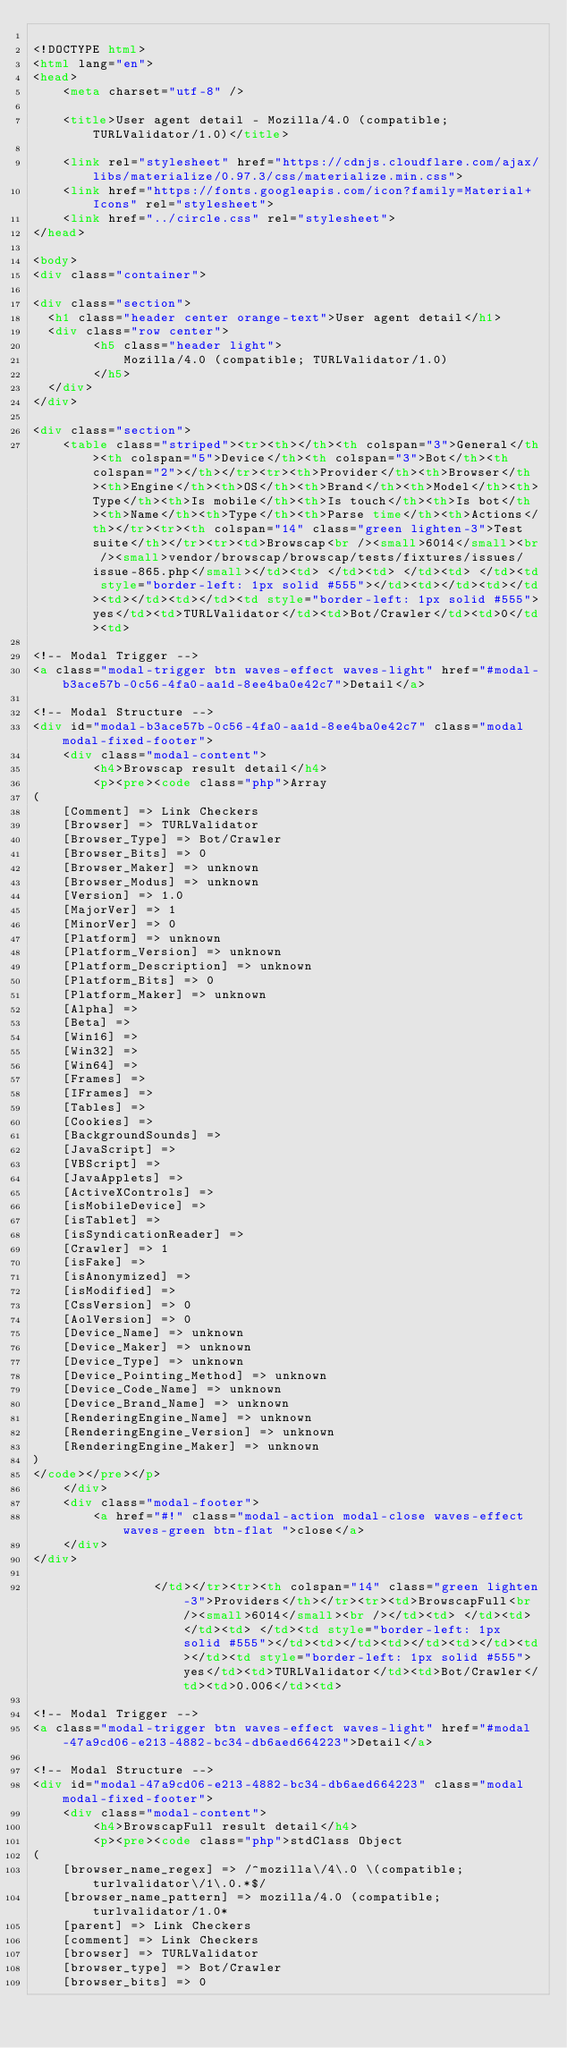Convert code to text. <code><loc_0><loc_0><loc_500><loc_500><_HTML_>
<!DOCTYPE html>
<html lang="en">
<head>
    <meta charset="utf-8" />
            
    <title>User agent detail - Mozilla/4.0 (compatible; TURLValidator/1.0)</title>
        
    <link rel="stylesheet" href="https://cdnjs.cloudflare.com/ajax/libs/materialize/0.97.3/css/materialize.min.css">
    <link href="https://fonts.googleapis.com/icon?family=Material+Icons" rel="stylesheet">
    <link href="../circle.css" rel="stylesheet">
</head>
        
<body>
<div class="container">
    
<div class="section">
	<h1 class="header center orange-text">User agent detail</h1>
	<div class="row center">
        <h5 class="header light">
            Mozilla/4.0 (compatible; TURLValidator/1.0)
        </h5>
	</div>
</div>   

<div class="section">
    <table class="striped"><tr><th></th><th colspan="3">General</th><th colspan="5">Device</th><th colspan="3">Bot</th><th colspan="2"></th></tr><tr><th>Provider</th><th>Browser</th><th>Engine</th><th>OS</th><th>Brand</th><th>Model</th><th>Type</th><th>Is mobile</th><th>Is touch</th><th>Is bot</th><th>Name</th><th>Type</th><th>Parse time</th><th>Actions</th></tr><tr><th colspan="14" class="green lighten-3">Test suite</th></tr><tr><td>Browscap<br /><small>6014</small><br /><small>vendor/browscap/browscap/tests/fixtures/issues/issue-865.php</small></td><td> </td><td> </td><td> </td><td style="border-left: 1px solid #555"></td><td></td><td></td><td></td><td></td><td style="border-left: 1px solid #555">yes</td><td>TURLValidator</td><td>Bot/Crawler</td><td>0</td><td>
        
<!-- Modal Trigger -->
<a class="modal-trigger btn waves-effect waves-light" href="#modal-b3ace57b-0c56-4fa0-aa1d-8ee4ba0e42c7">Detail</a>
        
<!-- Modal Structure -->
<div id="modal-b3ace57b-0c56-4fa0-aa1d-8ee4ba0e42c7" class="modal modal-fixed-footer">
    <div class="modal-content">
        <h4>Browscap result detail</h4>
        <p><pre><code class="php">Array
(
    [Comment] => Link Checkers
    [Browser] => TURLValidator
    [Browser_Type] => Bot/Crawler
    [Browser_Bits] => 0
    [Browser_Maker] => unknown
    [Browser_Modus] => unknown
    [Version] => 1.0
    [MajorVer] => 1
    [MinorVer] => 0
    [Platform] => unknown
    [Platform_Version] => unknown
    [Platform_Description] => unknown
    [Platform_Bits] => 0
    [Platform_Maker] => unknown
    [Alpha] => 
    [Beta] => 
    [Win16] => 
    [Win32] => 
    [Win64] => 
    [Frames] => 
    [IFrames] => 
    [Tables] => 
    [Cookies] => 
    [BackgroundSounds] => 
    [JavaScript] => 
    [VBScript] => 
    [JavaApplets] => 
    [ActiveXControls] => 
    [isMobileDevice] => 
    [isTablet] => 
    [isSyndicationReader] => 
    [Crawler] => 1
    [isFake] => 
    [isAnonymized] => 
    [isModified] => 
    [CssVersion] => 0
    [AolVersion] => 0
    [Device_Name] => unknown
    [Device_Maker] => unknown
    [Device_Type] => unknown
    [Device_Pointing_Method] => unknown
    [Device_Code_Name] => unknown
    [Device_Brand_Name] => unknown
    [RenderingEngine_Name] => unknown
    [RenderingEngine_Version] => unknown
    [RenderingEngine_Maker] => unknown
)
</code></pre></p>
    </div>
    <div class="modal-footer">
        <a href="#!" class="modal-action modal-close waves-effect waves-green btn-flat ">close</a>
    </div>
</div>
        
                </td></tr><tr><th colspan="14" class="green lighten-3">Providers</th></tr><tr><td>BrowscapFull<br /><small>6014</small><br /></td><td> </td><td> </td><td> </td><td style="border-left: 1px solid #555"></td><td></td><td></td><td></td><td></td><td style="border-left: 1px solid #555">yes</td><td>TURLValidator</td><td>Bot/Crawler</td><td>0.006</td><td>
        
<!-- Modal Trigger -->
<a class="modal-trigger btn waves-effect waves-light" href="#modal-47a9cd06-e213-4882-bc34-db6aed664223">Detail</a>
        
<!-- Modal Structure -->
<div id="modal-47a9cd06-e213-4882-bc34-db6aed664223" class="modal modal-fixed-footer">
    <div class="modal-content">
        <h4>BrowscapFull result detail</h4>
        <p><pre><code class="php">stdClass Object
(
    [browser_name_regex] => /^mozilla\/4\.0 \(compatible; turlvalidator\/1\.0.*$/
    [browser_name_pattern] => mozilla/4.0 (compatible; turlvalidator/1.0*
    [parent] => Link Checkers
    [comment] => Link Checkers
    [browser] => TURLValidator
    [browser_type] => Bot/Crawler
    [browser_bits] => 0</code> 